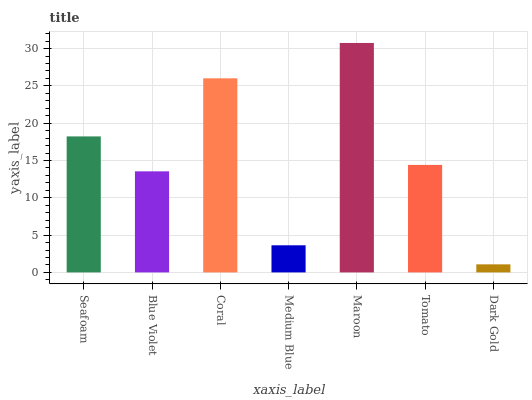Is Dark Gold the minimum?
Answer yes or no. Yes. Is Maroon the maximum?
Answer yes or no. Yes. Is Blue Violet the minimum?
Answer yes or no. No. Is Blue Violet the maximum?
Answer yes or no. No. Is Seafoam greater than Blue Violet?
Answer yes or no. Yes. Is Blue Violet less than Seafoam?
Answer yes or no. Yes. Is Blue Violet greater than Seafoam?
Answer yes or no. No. Is Seafoam less than Blue Violet?
Answer yes or no. No. Is Tomato the high median?
Answer yes or no. Yes. Is Tomato the low median?
Answer yes or no. Yes. Is Medium Blue the high median?
Answer yes or no. No. Is Maroon the low median?
Answer yes or no. No. 